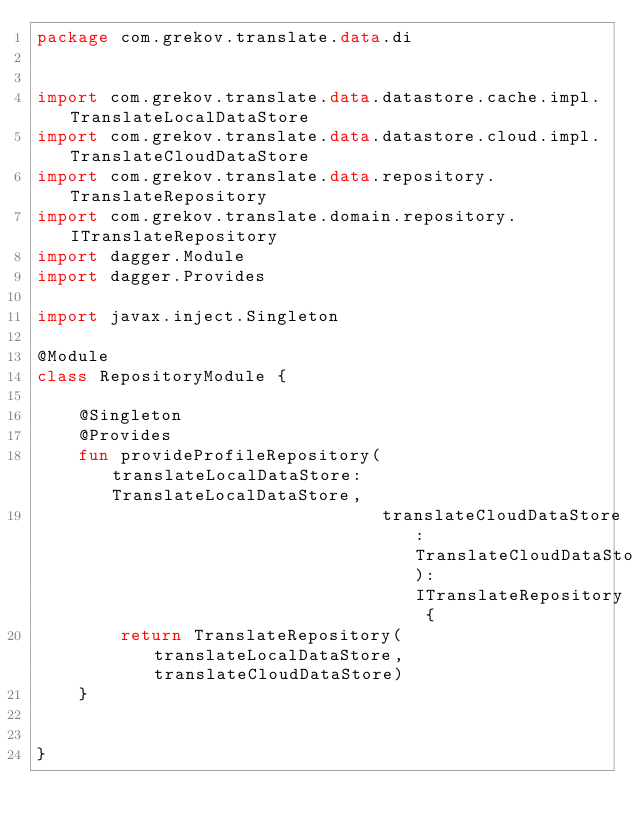Convert code to text. <code><loc_0><loc_0><loc_500><loc_500><_Kotlin_>package com.grekov.translate.data.di


import com.grekov.translate.data.datastore.cache.impl.TranslateLocalDataStore
import com.grekov.translate.data.datastore.cloud.impl.TranslateCloudDataStore
import com.grekov.translate.data.repository.TranslateRepository
import com.grekov.translate.domain.repository.ITranslateRepository
import dagger.Module
import dagger.Provides

import javax.inject.Singleton

@Module
class RepositoryModule {

    @Singleton
    @Provides
    fun provideProfileRepository(translateLocalDataStore: TranslateLocalDataStore,
                                 translateCloudDataStore: TranslateCloudDataStore): ITranslateRepository {
        return TranslateRepository(translateLocalDataStore, translateCloudDataStore)
    }


}
</code> 